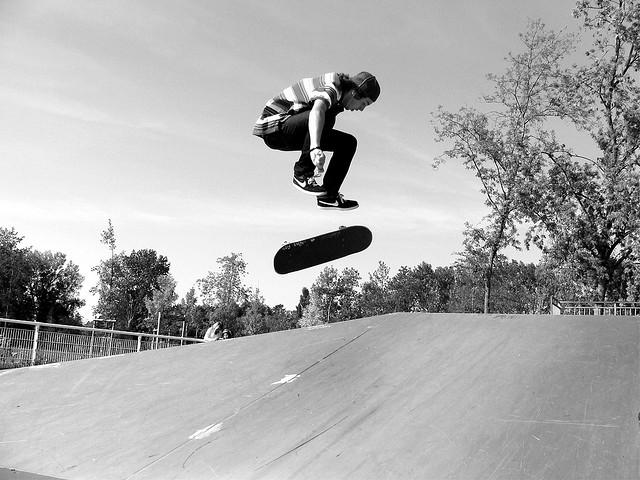Will the skateboard land on the ground?
Quick response, please. Yes. Is this a store parking lot?
Short answer required. No. Does this look like a skate park on the road?
Concise answer only. Yes. Are the stripes on his shirt horizontal?
Write a very short answer. Yes. Is the photo in color?
Quick response, please. No. 